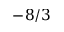<formula> <loc_0><loc_0><loc_500><loc_500>- 8 / 3</formula> 